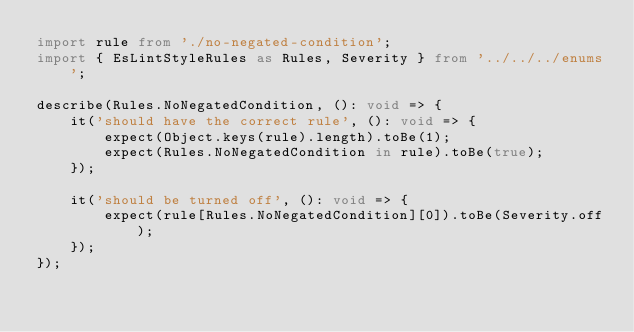Convert code to text. <code><loc_0><loc_0><loc_500><loc_500><_TypeScript_>import rule from './no-negated-condition';
import { EsLintStyleRules as Rules, Severity } from '../../../enums';

describe(Rules.NoNegatedCondition, (): void => {
	it('should have the correct rule', (): void => {
		expect(Object.keys(rule).length).toBe(1);
		expect(Rules.NoNegatedCondition in rule).toBe(true);
	});

	it('should be turned off', (): void => {
		expect(rule[Rules.NoNegatedCondition][0]).toBe(Severity.off);
	});
});
</code> 